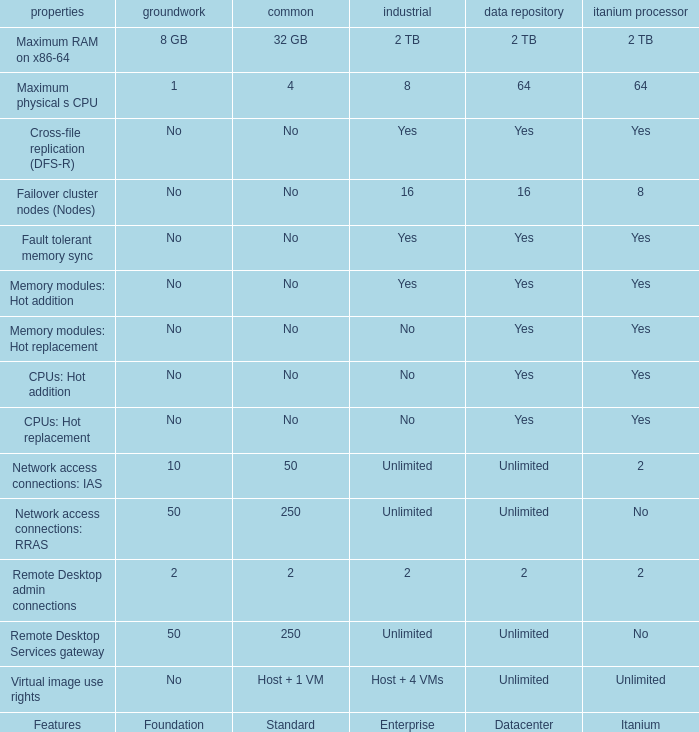Which datacenter has the "hot addition" feature for memory modules with a "yes" listed for itanium? Yes. 